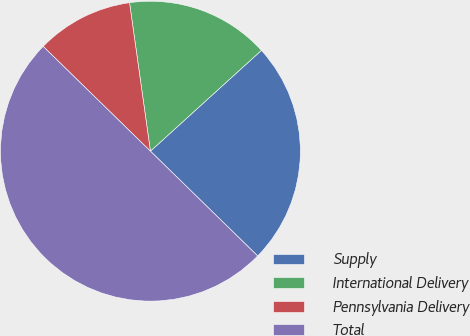Convert chart. <chart><loc_0><loc_0><loc_500><loc_500><pie_chart><fcel>Supply<fcel>International Delivery<fcel>Pennsylvania Delivery<fcel>Total<nl><fcel>24.05%<fcel>15.49%<fcel>10.46%<fcel>50.0%<nl></chart> 